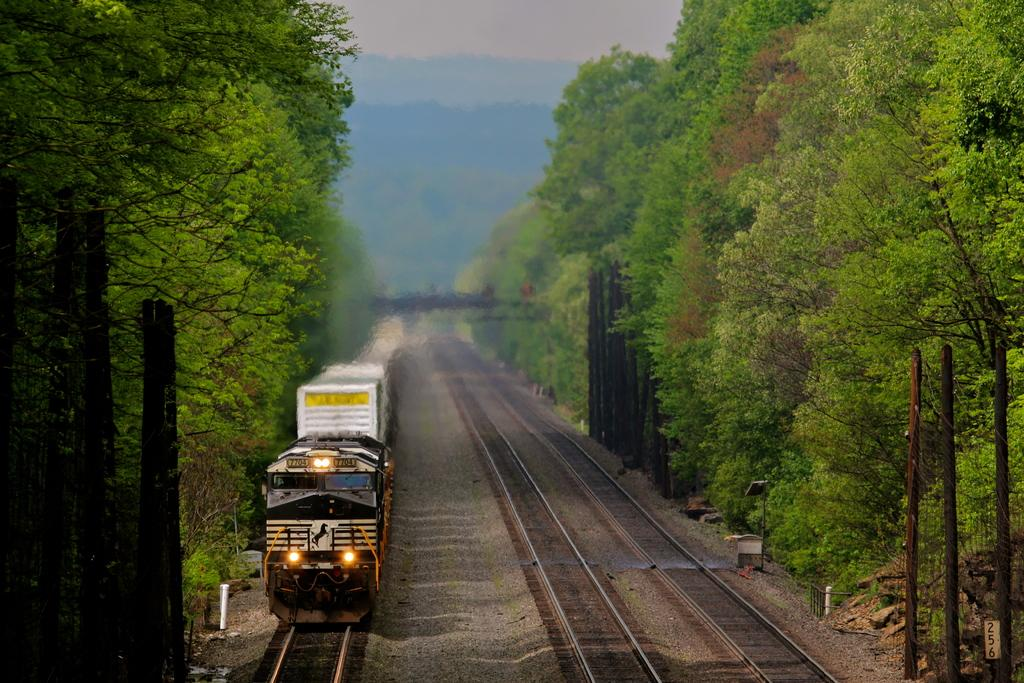What is the main subject of the image? The main subject of the image is a train. Where is the train located in the image? The train is on the left side of the image. What is the train resting on? The train is on tracks. What can be seen beside the train? There are trees beside the train. What type of beam is holding up the trees in the image? There is no beam present in the image; the trees are standing on their own. Can you see any brushes being used by the train in the image? There are no brushes visible in the image, and the train is not using any tools. 